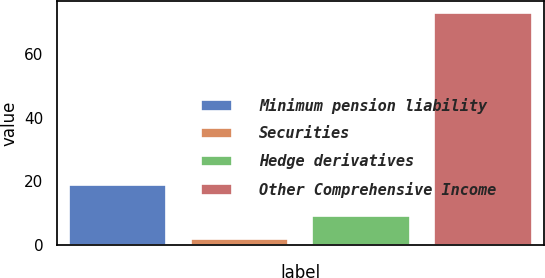Convert chart. <chart><loc_0><loc_0><loc_500><loc_500><bar_chart><fcel>Minimum pension liability<fcel>Securities<fcel>Hedge derivatives<fcel>Other Comprehensive Income<nl><fcel>19<fcel>2<fcel>9.1<fcel>73<nl></chart> 